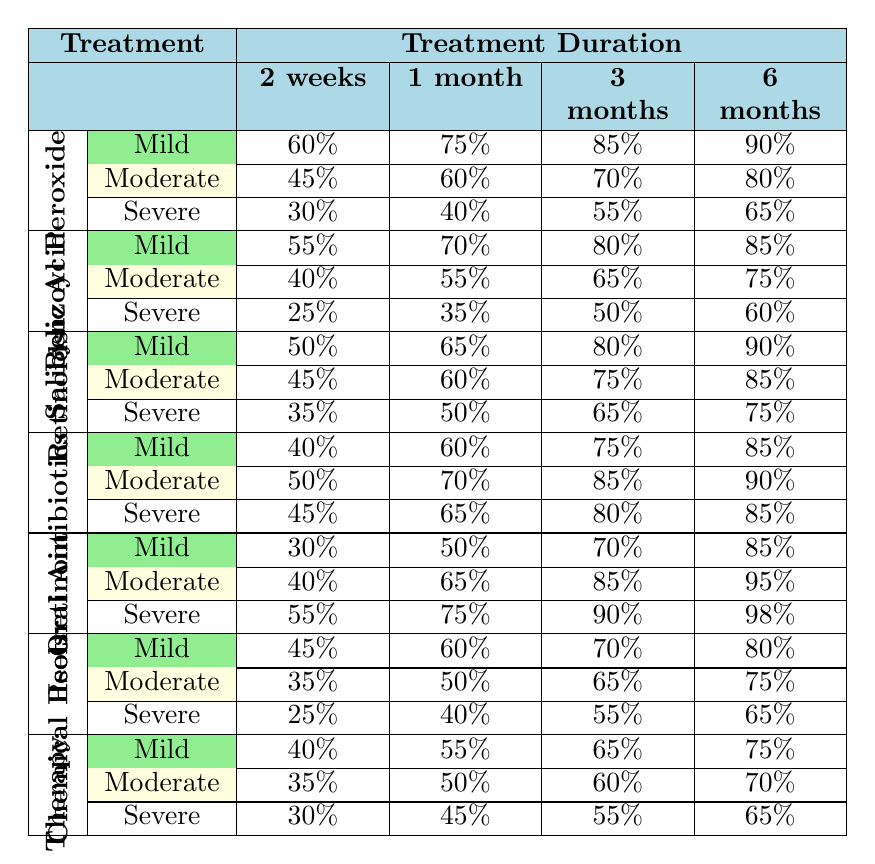What is the effectiveness of Benzoyl Peroxide for Mild acne after 6 months? According to the table, the effectiveness of Benzoyl Peroxide for Mild acne after 6 months is 90%.
Answer: 90% What is the highest effectiveness of Salicylic Acid across all severities and durations? Looking through the effectiveness values for Salicylic Acid, the highest value is 85%, which corresponds to Mild acne after 6 months.
Answer: 85% Is the effectiveness of Isotretinoin for Severe acne after 2 weeks higher than that of Oral Antibiotics for Severe acne after the same duration? The effectiveness of Isotretinoin for Severe acne after 2 weeks is 55%, while the effectiveness of Oral Antibiotics for Severe acne after 2 weeks is 45%. Since 55% is greater than 45%, the statement is true.
Answer: Yes What is the average effectiveness of Light Therapy for Moderate acne across all treatment durations? To calculate the average effectiveness for Light Therapy with Moderate acne, sum the effectiveness percentages (35% + 50% + 60% + 70%) = 215%. There are 4 durations, so the average is 215% / 4 = 53.75%.
Answer: 53.75% Which treatment shows the most significant increase in effectiveness from 1 month to 6 months for Moderate acne? For Moderate acne, the effectiveness for Benzoyl Peroxide at 1 month is 60% and at 6 months is 80%, giving an increase of 20%. For Oral Antibiotics, the increase is from 70% to 90% (20%). For Isotretinoin, the increase is 65% to 95% (30%). Therefore, Isotretinoin shows the most significant increase with 30%.
Answer: Isotretinoin How does the effectiveness of Chemical Peels compare for Severe acne against Mild acne after 3 months? For Severe acne, the effectiveness of Chemical Peels after 3 months is 55%. For Mild acne, it is 70%. Comparing these values, 70% is greater than 55%, which indicates that the effectiveness for Mild acne is higher than for Severe.
Answer: Effectiveness is higher for Mild acne 